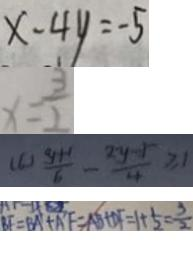Convert formula to latex. <formula><loc_0><loc_0><loc_500><loc_500>x - 4 y = - 5 
 x = \frac { 3 } { 2 } 
 ( 6 ) \frac { y + 1 } { 6 } - \frac { 2 y - 5 } { 4 } \geq 1 
 B F = B A + A F = A B + D F = 1 + \frac { 1 } { 2 } = \frac { 3 } { 2 }</formula> 